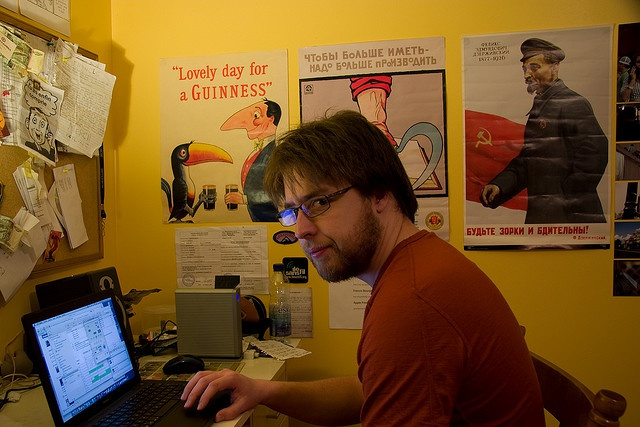Describe the objects in this image and their specific colors. I can see people in olive, maroon, black, and brown tones, laptop in olive, black, darkgray, lightblue, and maroon tones, chair in olive, black, and maroon tones, bottle in olive and black tones, and mouse in olive, black, darkgreen, and gray tones in this image. 